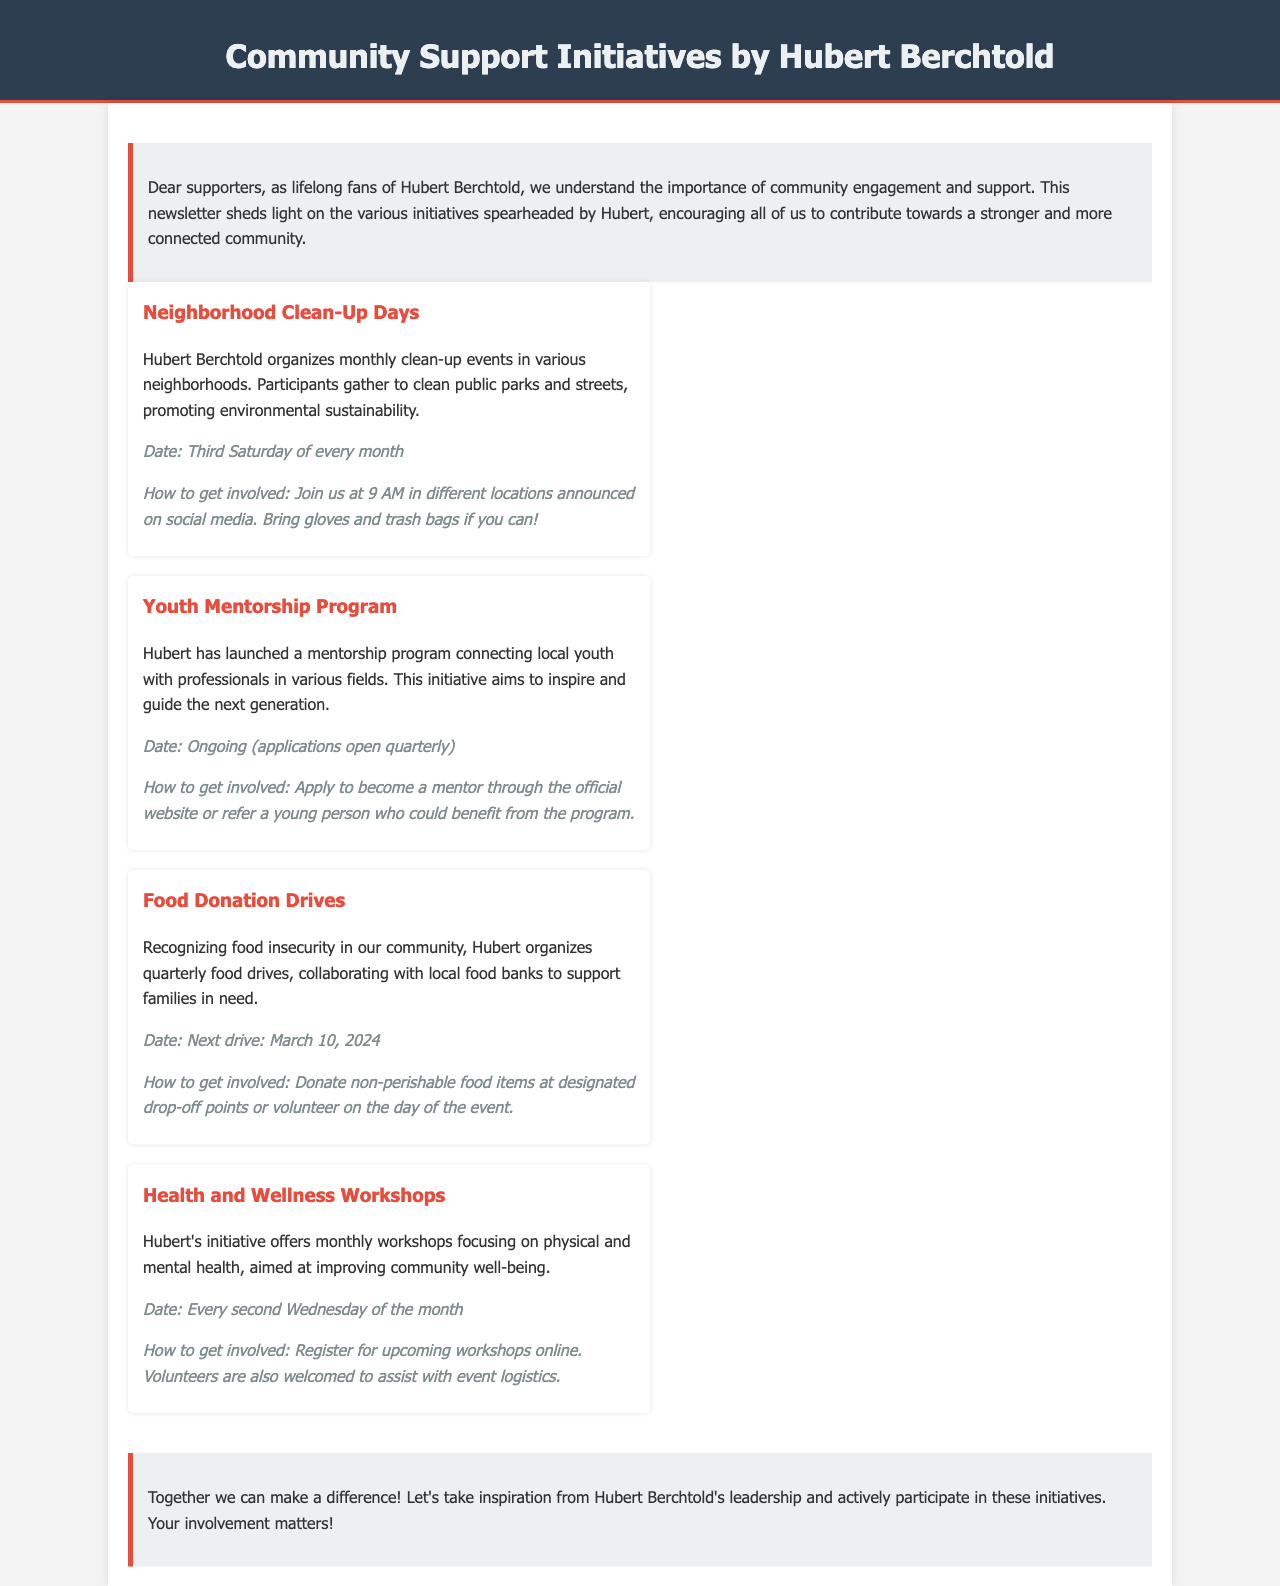What are Neighborhood Clean-Up Days? Neighborhood Clean-Up Days are monthly clean-up events in neighborhoods for environmental sustainability.
Answer: Monthly clean-up events When do Youth Mentorship Program applications open? Applications for the Youth Mentorship Program open quarterly as stated in the newsletter.
Answer: Quarterly What is the next Food Donation Drive date? The next Food Donation Drive is scheduled for March 10, 2024, as mentioned in the initiative.
Answer: March 10, 2024 How frequently do Health and Wellness Workshops occur? Health and Wellness Workshops occur every second Wednesday of the month, indicated in the schedule.
Answer: Every second Wednesday How can someone volunteer for the Food Donation Drive? Volunteers can assist on the day of the event, as noted in the Food Donation Drives description.
Answer: On the day of the event What is the focus of the Health and Wellness Workshops? The focus of the Health and Wellness Workshops is on improving community well-being.
Answer: Improving community well-being Who organizes the Neighborhood Clean-Up Days? The Neighborhood Clean-Up Days are organized by Hubert Berchtold.
Answer: Hubert Berchtold What should participants bring to the clean-up event? Participants are encouraged to bring gloves and trash bags, as stated in the how-to section for this initiative.
Answer: Gloves and trash bags 